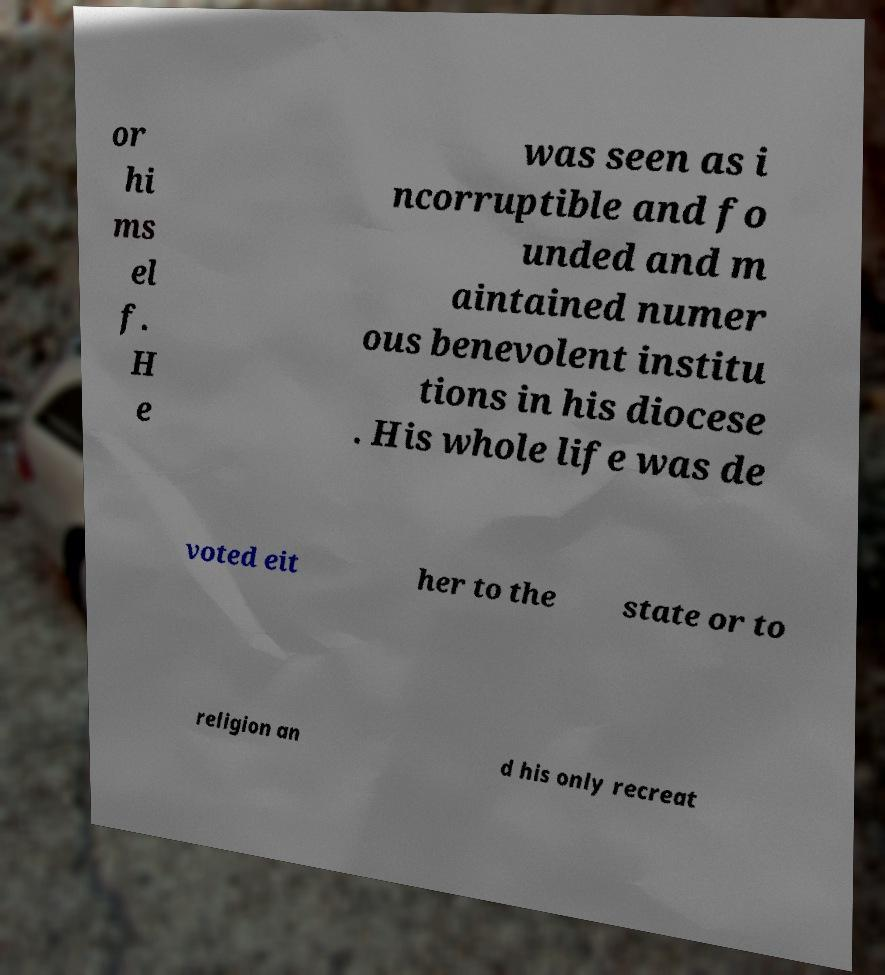Please read and relay the text visible in this image. What does it say? or hi ms el f. H e was seen as i ncorruptible and fo unded and m aintained numer ous benevolent institu tions in his diocese . His whole life was de voted eit her to the state or to religion an d his only recreat 